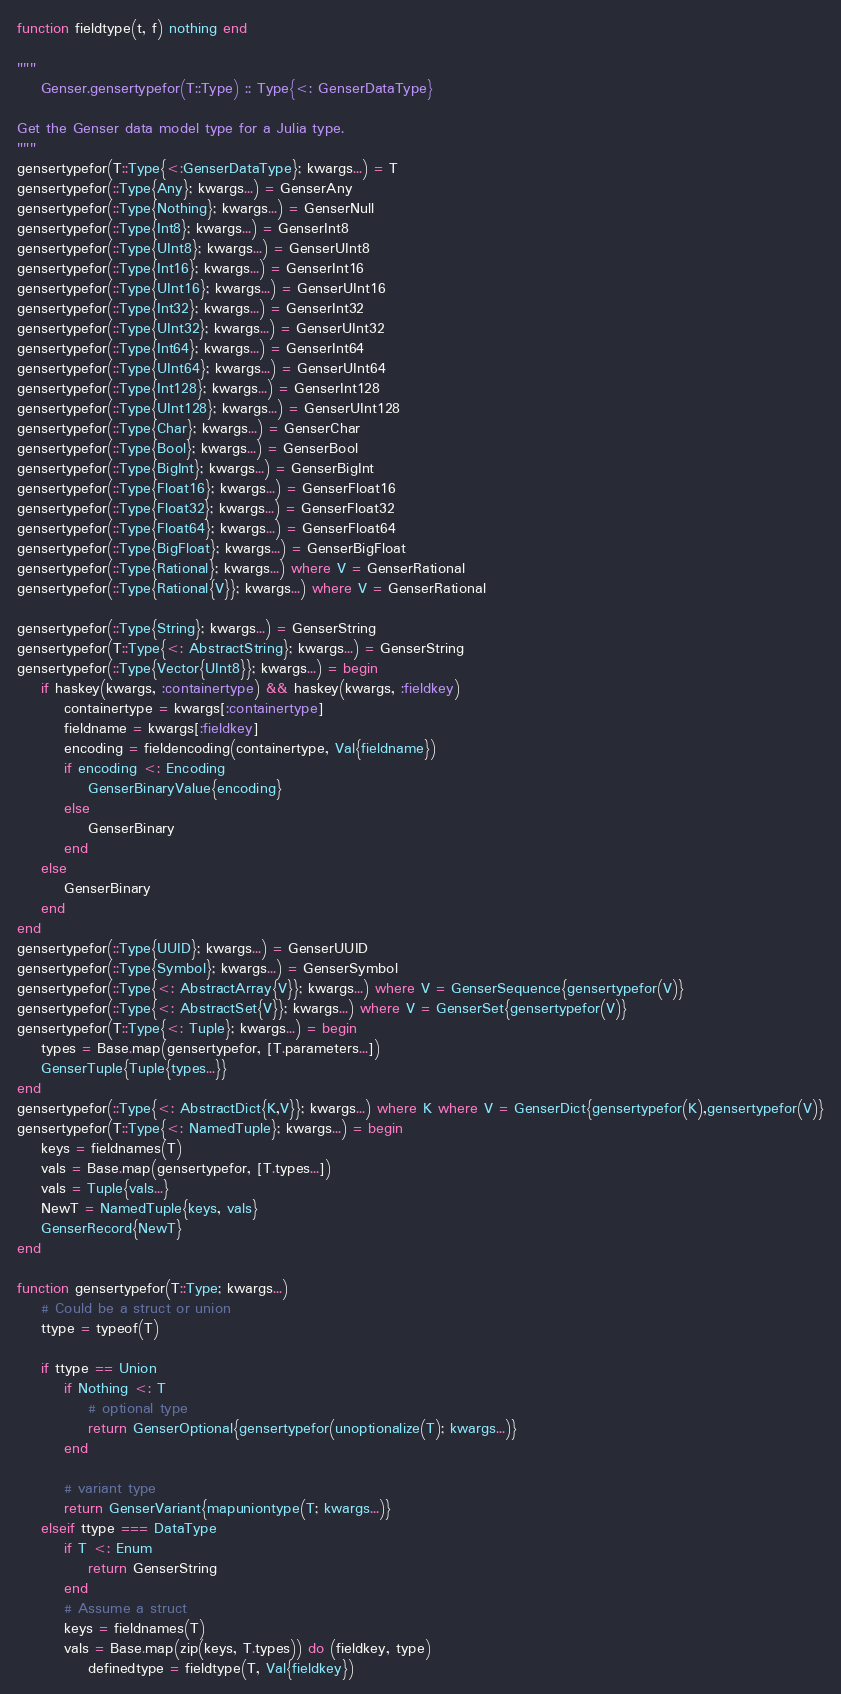Convert code to text. <code><loc_0><loc_0><loc_500><loc_500><_Julia_>function fieldtype(t, f) nothing end

"""
    Genser.gensertypefor(T::Type) :: Type{<: GenserDataType}

Get the Genser data model type for a Julia type.
"""
gensertypefor(T::Type{<:GenserDataType}; kwargs...) = T
gensertypefor(::Type{Any}; kwargs...) = GenserAny
gensertypefor(::Type{Nothing}; kwargs...) = GenserNull
gensertypefor(::Type{Int8}; kwargs...) = GenserInt8
gensertypefor(::Type{UInt8}; kwargs...) = GenserUInt8
gensertypefor(::Type{Int16}; kwargs...) = GenserInt16
gensertypefor(::Type{UInt16}; kwargs...) = GenserUInt16
gensertypefor(::Type{Int32}; kwargs...) = GenserInt32
gensertypefor(::Type{UInt32}; kwargs...) = GenserUInt32
gensertypefor(::Type{Int64}; kwargs...) = GenserInt64
gensertypefor(::Type{UInt64}; kwargs...) = GenserUInt64
gensertypefor(::Type{Int128}; kwargs...) = GenserInt128
gensertypefor(::Type{UInt128}; kwargs...) = GenserUInt128
gensertypefor(::Type{Char}; kwargs...) = GenserChar
gensertypefor(::Type{Bool}; kwargs...) = GenserBool
gensertypefor(::Type{BigInt}; kwargs...) = GenserBigInt
gensertypefor(::Type{Float16}; kwargs...) = GenserFloat16
gensertypefor(::Type{Float32}; kwargs...) = GenserFloat32
gensertypefor(::Type{Float64}; kwargs...) = GenserFloat64
gensertypefor(::Type{BigFloat}; kwargs...) = GenserBigFloat
gensertypefor(::Type{Rational}; kwargs...) where V = GenserRational
gensertypefor(::Type{Rational{V}}; kwargs...) where V = GenserRational

gensertypefor(::Type{String}; kwargs...) = GenserString
gensertypefor(T::Type{<: AbstractString}; kwargs...) = GenserString
gensertypefor(::Type{Vector{UInt8}}; kwargs...) = begin
    if haskey(kwargs, :containertype) && haskey(kwargs, :fieldkey)
        containertype = kwargs[:containertype]
        fieldname = kwargs[:fieldkey]
        encoding = fieldencoding(containertype, Val{fieldname})
        if encoding <: Encoding
            GenserBinaryValue{encoding}
        else
            GenserBinary
        end
    else
        GenserBinary
    end
end
gensertypefor(::Type{UUID}; kwargs...) = GenserUUID
gensertypefor(::Type{Symbol}; kwargs...) = GenserSymbol
gensertypefor(::Type{<: AbstractArray{V}}; kwargs...) where V = GenserSequence{gensertypefor(V)}
gensertypefor(::Type{<: AbstractSet{V}}; kwargs...) where V = GenserSet{gensertypefor(V)}
gensertypefor(T::Type{<: Tuple}; kwargs...) = begin
    types = Base.map(gensertypefor, [T.parameters...])
    GenserTuple{Tuple{types...}}
end
gensertypefor(::Type{<: AbstractDict{K,V}}; kwargs...) where K where V = GenserDict{gensertypefor(K),gensertypefor(V)}
gensertypefor(T::Type{<: NamedTuple}; kwargs...) = begin
    keys = fieldnames(T)
    vals = Base.map(gensertypefor, [T.types...])
    vals = Tuple{vals...}
    NewT = NamedTuple{keys, vals}
    GenserRecord{NewT}
end

function gensertypefor(T::Type; kwargs...)
    # Could be a struct or union
    ttype = typeof(T)

    if ttype == Union
        if Nothing <: T
            # optional type
            return GenserOptional{gensertypefor(unoptionalize(T); kwargs...)}
        end

        # variant type
        return GenserVariant{mapuniontype(T; kwargs...)}
    elseif ttype === DataType
        if T <: Enum
            return GenserString
        end
        # Assume a struct
        keys = fieldnames(T)
        vals = Base.map(zip(keys, T.types)) do (fieldkey, type)
            definedtype = fieldtype(T, Val{fieldkey})</code> 